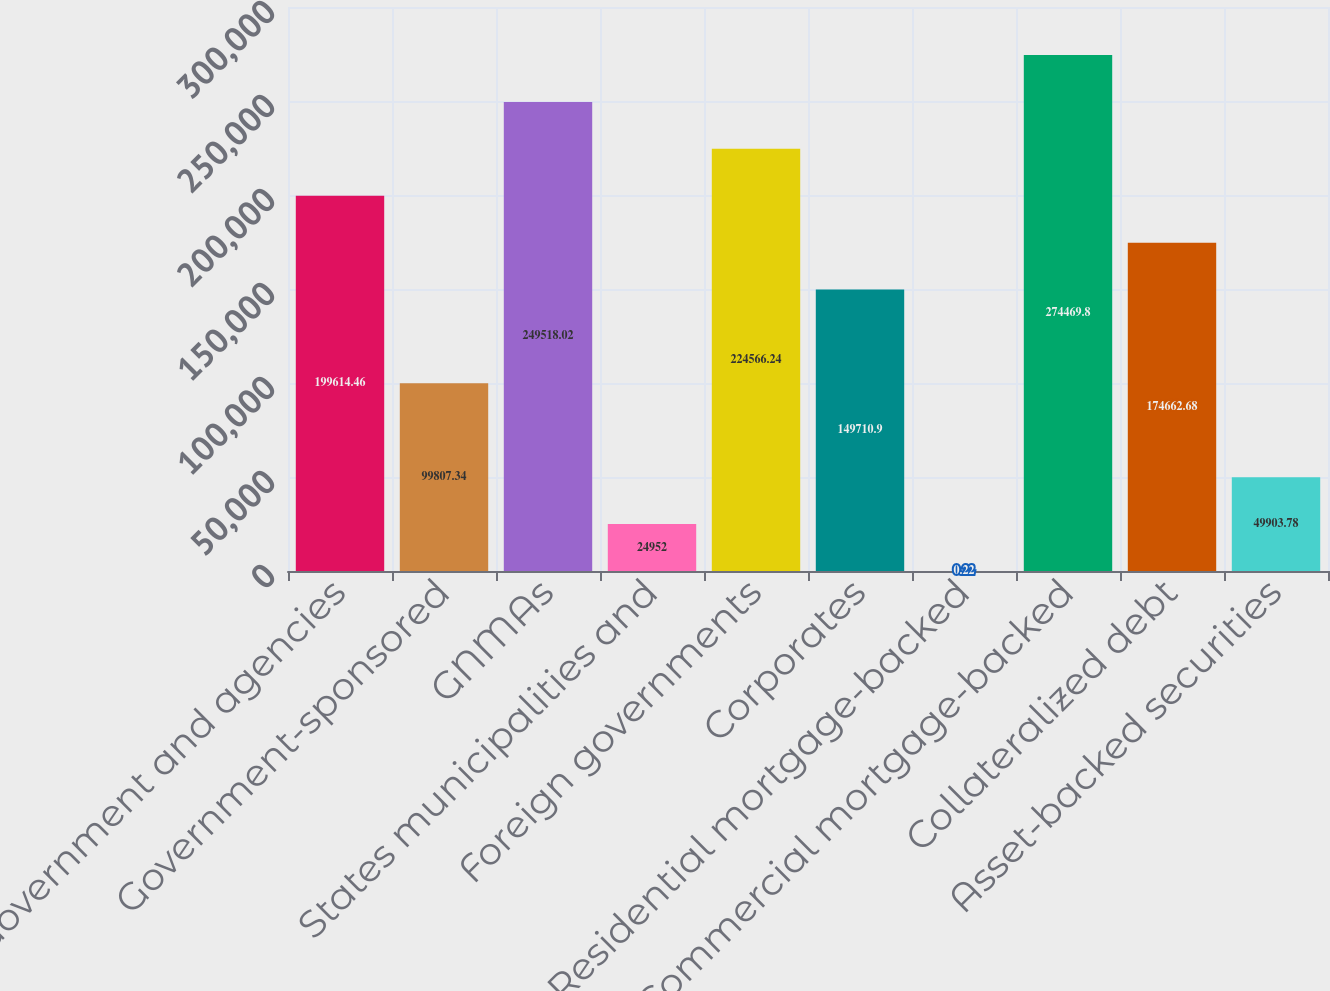Convert chart. <chart><loc_0><loc_0><loc_500><loc_500><bar_chart><fcel>US Government and agencies<fcel>Government-sponsored<fcel>GNMAs<fcel>States municipalities and<fcel>Foreign governments<fcel>Corporates<fcel>Residential mortgage-backed<fcel>Commercial mortgage-backed<fcel>Collateralized debt<fcel>Asset-backed securities<nl><fcel>199614<fcel>99807.3<fcel>249518<fcel>24952<fcel>224566<fcel>149711<fcel>0.22<fcel>274470<fcel>174663<fcel>49903.8<nl></chart> 